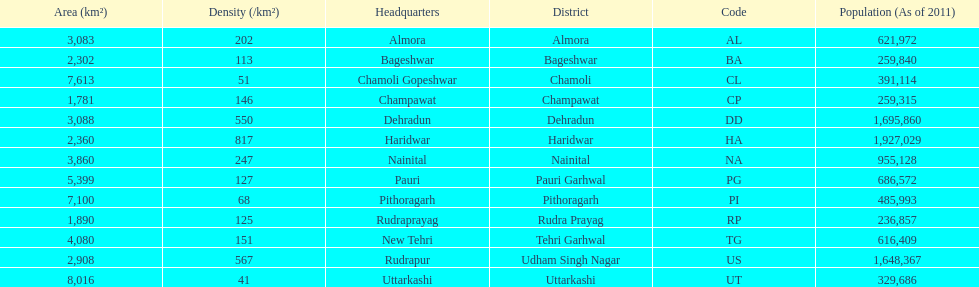Which has a larger population, dehradun or nainital? Dehradun. 